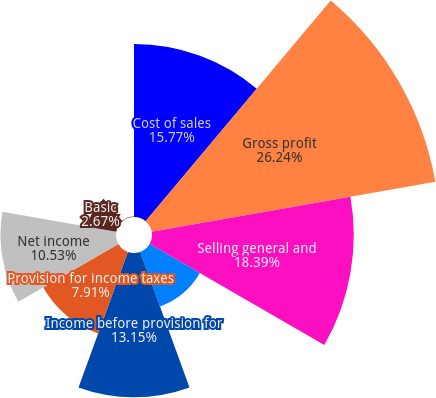<chart> <loc_0><loc_0><loc_500><loc_500><pie_chart><fcel>Cost of sales<fcel>Gross profit<fcel>Selling general and<fcel>Special (gains) charges(a)<fcel>Income before provision for<fcel>Provision for income taxes<fcel>Net income<fcel>Basic<fcel>Diluted<nl><fcel>15.77%<fcel>26.25%<fcel>18.39%<fcel>5.29%<fcel>13.15%<fcel>7.91%<fcel>10.53%<fcel>2.67%<fcel>0.05%<nl></chart> 